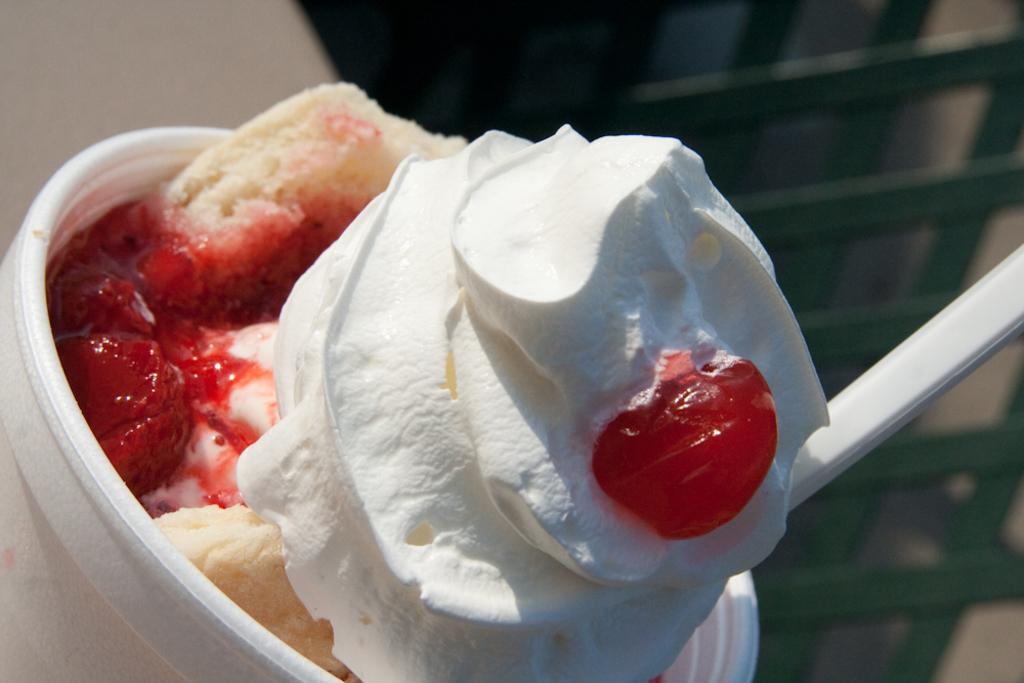What is in the cup that is visible in the image? The cup contains ice cream. What is used to eat the ice cream in the image? There is a spoon in the cup. What is placed on top of the spoon in the image? A cherry is on top of the spoon. What type of wing is visible on the ice cream in the image? There are no wings visible on the ice cream in the image. How does the spoon help in copying the ice cream in the image? The spoon is used for eating the ice cream, not for copying it, so this question is not relevant to the image. 